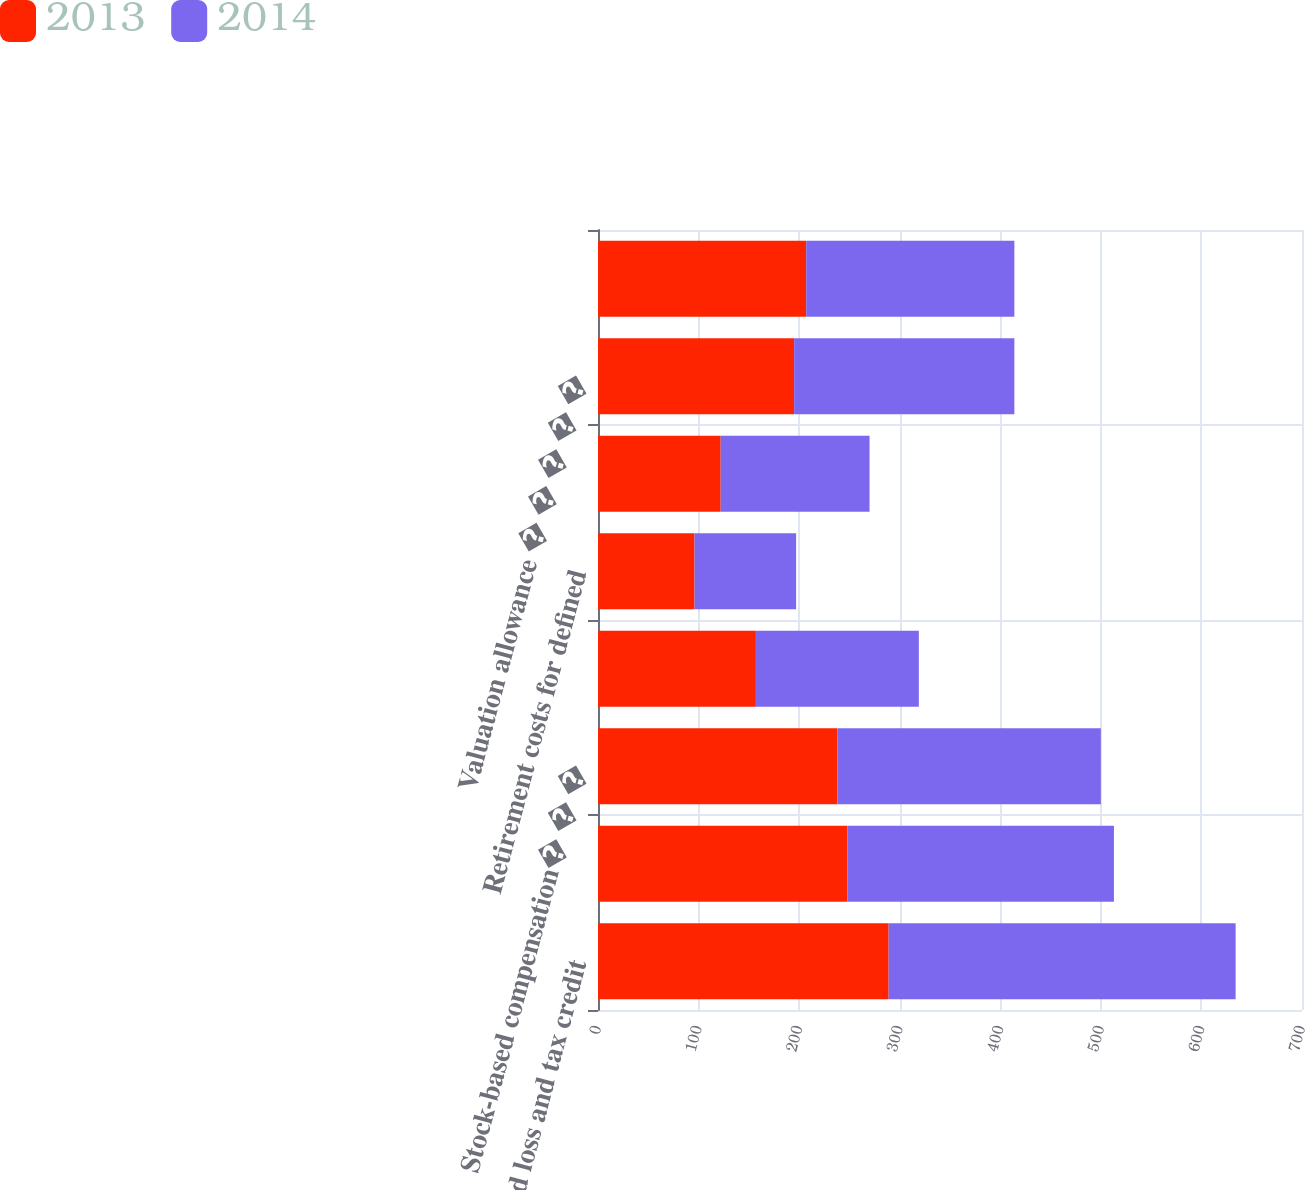<chart> <loc_0><loc_0><loc_500><loc_500><stacked_bar_chart><ecel><fcel>Deferred loss and tax credit<fcel>Accrued expenses � � � � � � �<fcel>Stock-based compensation� � �<fcel>Inventories and related<fcel>Retirement costs for defined<fcel>Other � � � � � � � � � � � �<fcel>Valuation allowance � � � � �<fcel>Acquisition-related<nl><fcel>2013<fcel>289<fcel>248<fcel>238<fcel>157<fcel>96<fcel>122<fcel>195<fcel>207<nl><fcel>2014<fcel>345<fcel>265<fcel>262<fcel>162<fcel>101<fcel>148<fcel>219<fcel>207<nl></chart> 